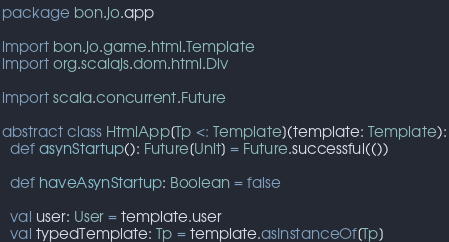<code> <loc_0><loc_0><loc_500><loc_500><_Scala_>package bon.jo.app

import bon.jo.game.html.Template
import org.scalajs.dom.html.Div

import scala.concurrent.Future

abstract class HtmlApp[Tp <: Template](template: Template):
  def asynStartup(): Future[Unit] = Future.successful(())

  def haveAsynStartup: Boolean = false

  val user: User = template.user
  val typedTemplate: Tp = template.asInstanceOf[Tp]
</code> 